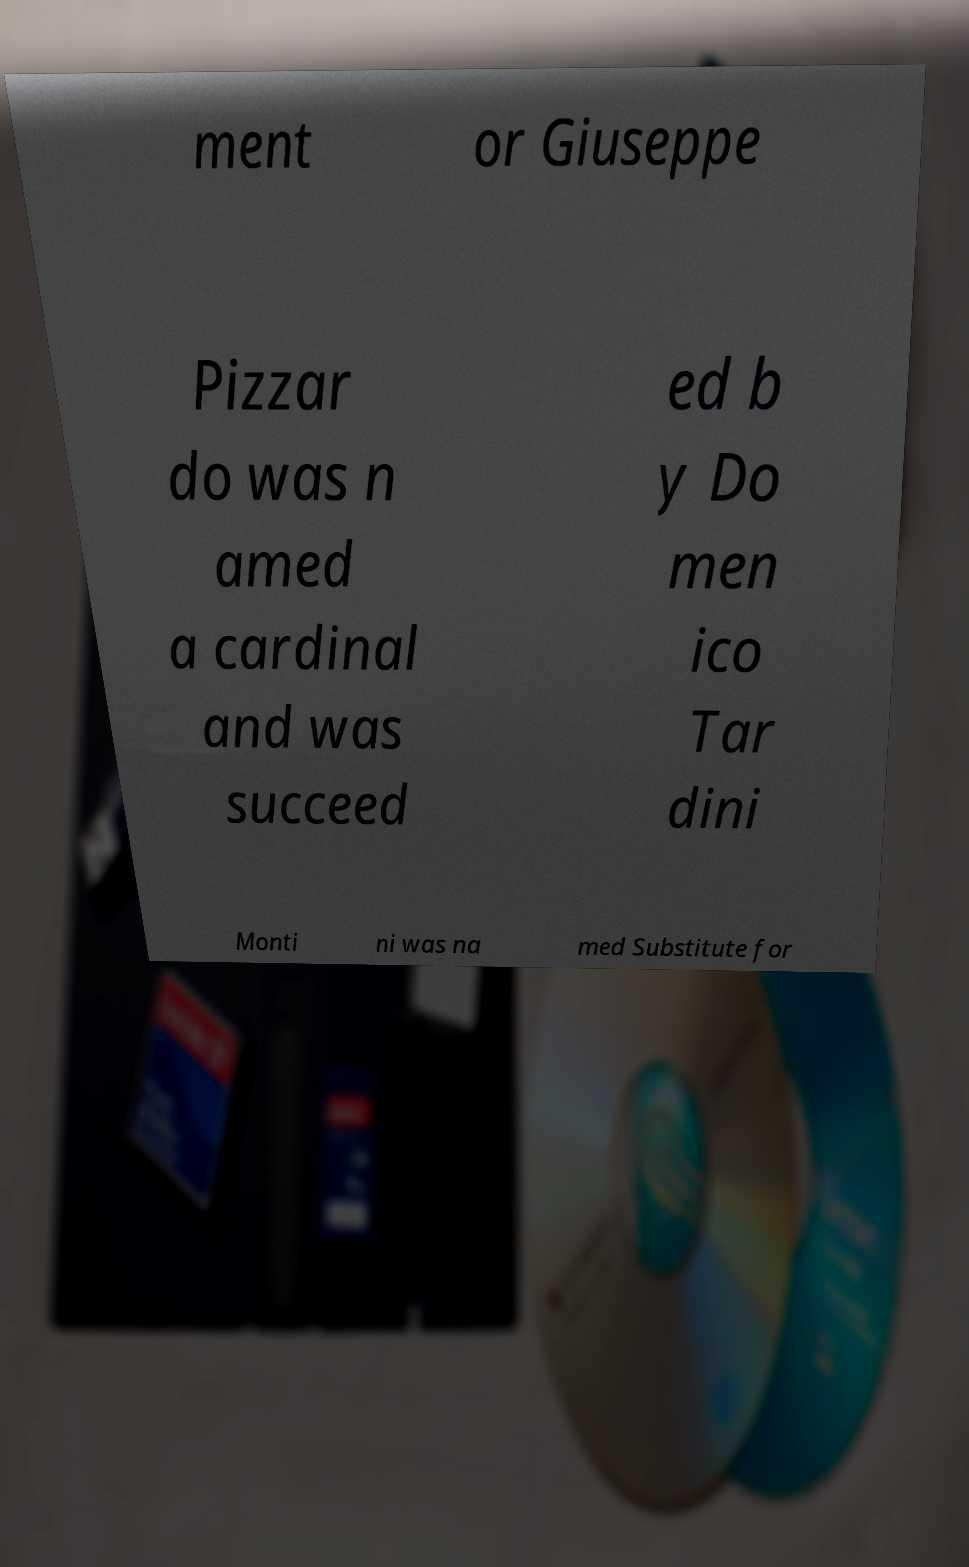Can you read and provide the text displayed in the image?This photo seems to have some interesting text. Can you extract and type it out for me? ment or Giuseppe Pizzar do was n amed a cardinal and was succeed ed b y Do men ico Tar dini Monti ni was na med Substitute for 